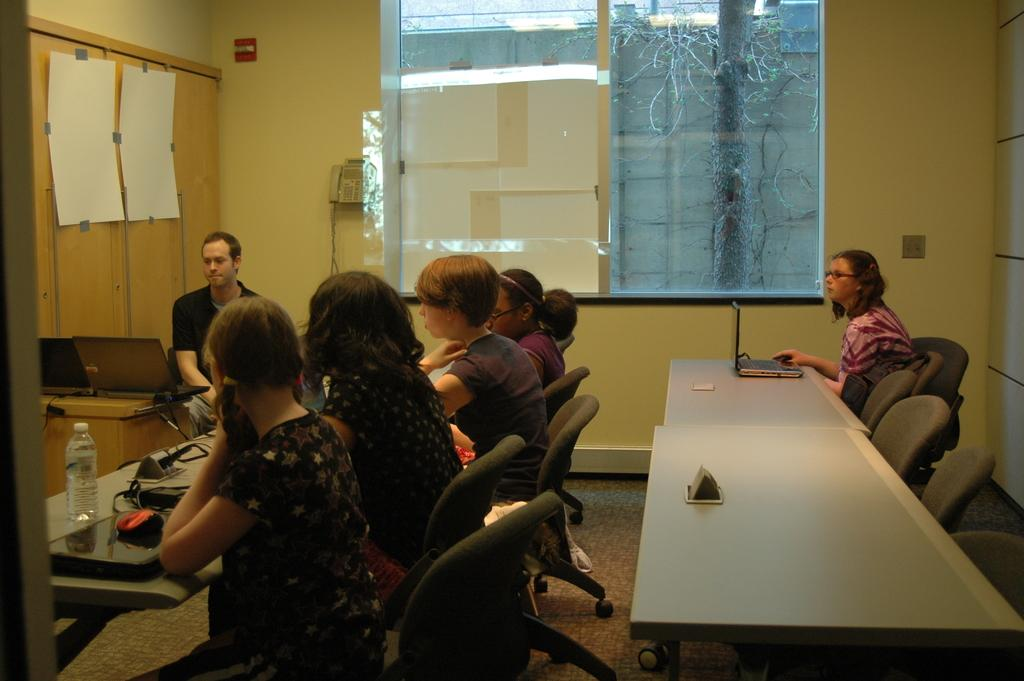How many people are sitting in the image? There are six people sitting on chairs in the image. What can be seen on the table in the image? There is a laptop and a bottle on the table in the image. How many mice are running around on the table in the image? There are no mice present in the image; only a laptop and a bottle are visible on the table. 